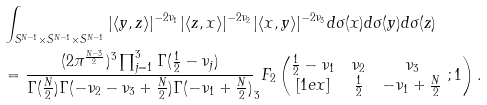<formula> <loc_0><loc_0><loc_500><loc_500>& \int _ { S ^ { N - 1 } \times S ^ { N - 1 } \times S ^ { N - 1 } } | \langle y , z \rangle | ^ { - 2 \nu _ { 1 } } | \langle z , x \rangle | ^ { - 2 \nu _ { 2 } } | \langle x , y \rangle | ^ { - 2 \nu _ { 3 } } d \sigma ( x ) d \sigma ( y ) d \sigma ( z ) \\ & = \frac { ( 2 \pi ^ { \frac { N - 3 } { 2 } } ) ^ { 3 } \prod _ { j = 1 } ^ { 3 } \Gamma ( \frac { 1 } { 2 } - \nu _ { j } ) } { \Gamma ( \frac { N } { 2 } ) \Gamma ( - \nu _ { 2 } - \nu _ { 3 } + \frac { N } { 2 } ) \Gamma ( - \nu _ { 1 } + \frac { N } { 2 } ) } _ { 3 } F _ { 2 } \left ( \begin{matrix} \frac { 1 } { 2 } - \nu _ { 1 } & \nu _ { 2 } & \nu _ { 3 } \\ [ 1 e x ] & \frac { 1 } { 2 } & - \nu _ { 1 } + \frac { N } { 2 } \end{matrix} \ ; 1 \right ) .</formula> 